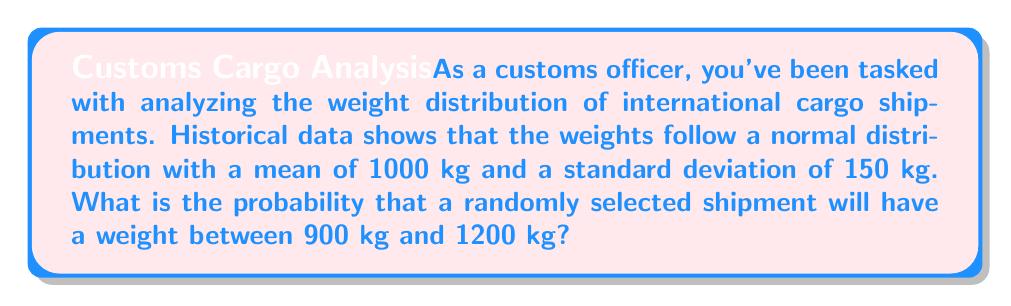Help me with this question. To solve this problem, we'll use the properties of the normal distribution and the concept of z-scores.

Step 1: Identify the given information
- Mean (μ) = 1000 kg
- Standard deviation (σ) = 150 kg
- Lower bound = 900 kg
- Upper bound = 1200 kg

Step 2: Calculate the z-scores for the lower and upper bounds
z-score formula: $z = \frac{x - \mu}{\sigma}$

For 900 kg: $z_1 = \frac{900 - 1000}{150} = -\frac{2}{3} \approx -0.67$

For 1200 kg: $z_2 = \frac{1200 - 1000}{150} = \frac{4}{3} \approx 1.33$

Step 3: Use the standard normal distribution table or a calculator to find the area under the curve between these z-scores

The probability is equal to the area between $z_1$ and $z_2$.

$P(-0.67 < Z < 1.33) = P(Z < 1.33) - P(Z < -0.67)$

Using a standard normal distribution table or calculator:

$P(Z < 1.33) \approx 0.9082$
$P(Z < -0.67) \approx 0.2514$

Step 4: Calculate the final probability
$P(900 < X < 1200) = 0.9082 - 0.2514 = 0.6568$

Therefore, the probability that a randomly selected shipment will have a weight between 900 kg and 1200 kg is approximately 0.6568 or 65.68%.
Answer: 0.6568 